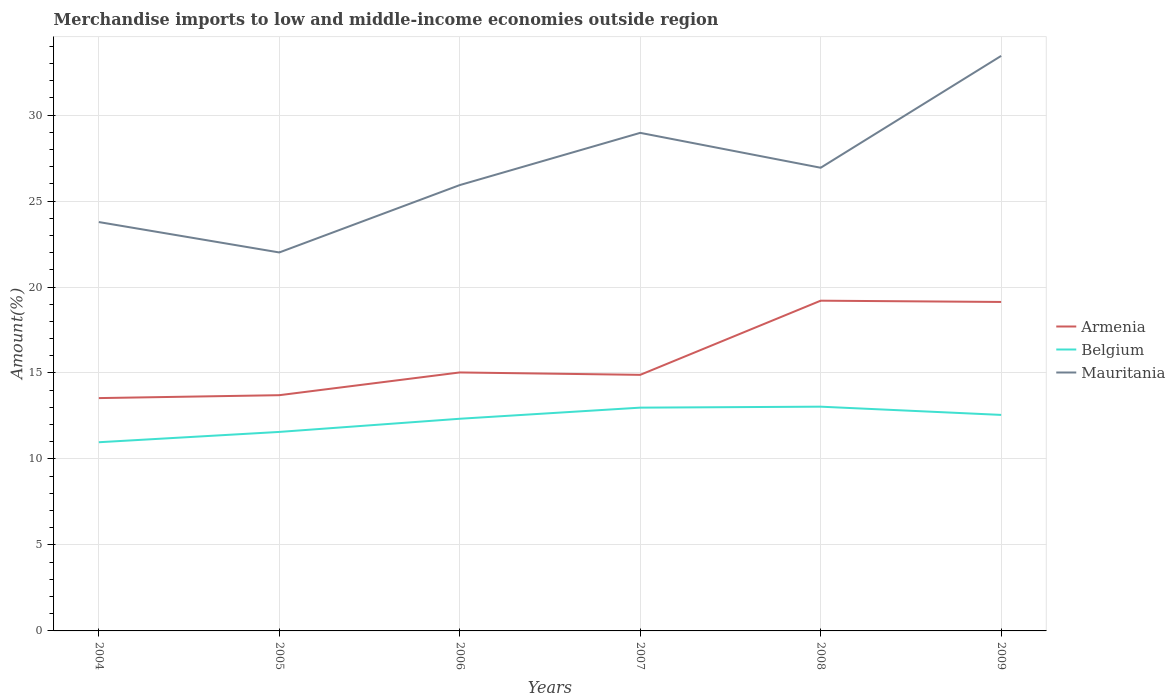Is the number of lines equal to the number of legend labels?
Your response must be concise. Yes. Across all years, what is the maximum percentage of amount earned from merchandise imports in Armenia?
Provide a short and direct response. 13.54. What is the total percentage of amount earned from merchandise imports in Armenia in the graph?
Provide a short and direct response. -4.17. What is the difference between the highest and the second highest percentage of amount earned from merchandise imports in Mauritania?
Keep it short and to the point. 11.43. What is the difference between the highest and the lowest percentage of amount earned from merchandise imports in Mauritania?
Your response must be concise. 3. Is the percentage of amount earned from merchandise imports in Belgium strictly greater than the percentage of amount earned from merchandise imports in Mauritania over the years?
Make the answer very short. Yes. How many lines are there?
Your response must be concise. 3. How many years are there in the graph?
Your answer should be compact. 6. Does the graph contain grids?
Provide a succinct answer. Yes. How many legend labels are there?
Your answer should be very brief. 3. How are the legend labels stacked?
Your response must be concise. Vertical. What is the title of the graph?
Keep it short and to the point. Merchandise imports to low and middle-income economies outside region. What is the label or title of the Y-axis?
Your answer should be compact. Amount(%). What is the Amount(%) of Armenia in 2004?
Your response must be concise. 13.54. What is the Amount(%) in Belgium in 2004?
Your answer should be very brief. 10.97. What is the Amount(%) of Mauritania in 2004?
Offer a terse response. 23.78. What is the Amount(%) in Armenia in 2005?
Keep it short and to the point. 13.71. What is the Amount(%) in Belgium in 2005?
Keep it short and to the point. 11.57. What is the Amount(%) in Mauritania in 2005?
Your response must be concise. 22.01. What is the Amount(%) in Armenia in 2006?
Your answer should be compact. 15.03. What is the Amount(%) in Belgium in 2006?
Ensure brevity in your answer.  12.34. What is the Amount(%) of Mauritania in 2006?
Provide a succinct answer. 25.93. What is the Amount(%) in Armenia in 2007?
Provide a succinct answer. 14.89. What is the Amount(%) of Belgium in 2007?
Offer a very short reply. 12.98. What is the Amount(%) of Mauritania in 2007?
Your answer should be compact. 28.96. What is the Amount(%) of Armenia in 2008?
Give a very brief answer. 19.2. What is the Amount(%) in Belgium in 2008?
Make the answer very short. 13.04. What is the Amount(%) of Mauritania in 2008?
Give a very brief answer. 26.94. What is the Amount(%) in Armenia in 2009?
Keep it short and to the point. 19.13. What is the Amount(%) of Belgium in 2009?
Give a very brief answer. 12.56. What is the Amount(%) in Mauritania in 2009?
Your response must be concise. 33.44. Across all years, what is the maximum Amount(%) in Armenia?
Your answer should be very brief. 19.2. Across all years, what is the maximum Amount(%) of Belgium?
Your answer should be compact. 13.04. Across all years, what is the maximum Amount(%) of Mauritania?
Offer a very short reply. 33.44. Across all years, what is the minimum Amount(%) of Armenia?
Provide a succinct answer. 13.54. Across all years, what is the minimum Amount(%) in Belgium?
Your answer should be compact. 10.97. Across all years, what is the minimum Amount(%) of Mauritania?
Offer a terse response. 22.01. What is the total Amount(%) in Armenia in the graph?
Make the answer very short. 95.51. What is the total Amount(%) in Belgium in the graph?
Provide a succinct answer. 73.47. What is the total Amount(%) of Mauritania in the graph?
Provide a short and direct response. 161.05. What is the difference between the Amount(%) of Armenia in 2004 and that in 2005?
Provide a short and direct response. -0.17. What is the difference between the Amount(%) in Belgium in 2004 and that in 2005?
Keep it short and to the point. -0.6. What is the difference between the Amount(%) of Mauritania in 2004 and that in 2005?
Ensure brevity in your answer.  1.77. What is the difference between the Amount(%) of Armenia in 2004 and that in 2006?
Give a very brief answer. -1.49. What is the difference between the Amount(%) in Belgium in 2004 and that in 2006?
Your response must be concise. -1.36. What is the difference between the Amount(%) of Mauritania in 2004 and that in 2006?
Keep it short and to the point. -2.15. What is the difference between the Amount(%) of Armenia in 2004 and that in 2007?
Provide a short and direct response. -1.35. What is the difference between the Amount(%) in Belgium in 2004 and that in 2007?
Provide a succinct answer. -2.01. What is the difference between the Amount(%) in Mauritania in 2004 and that in 2007?
Keep it short and to the point. -5.19. What is the difference between the Amount(%) of Armenia in 2004 and that in 2008?
Your answer should be compact. -5.66. What is the difference between the Amount(%) of Belgium in 2004 and that in 2008?
Provide a short and direct response. -2.07. What is the difference between the Amount(%) in Mauritania in 2004 and that in 2008?
Make the answer very short. -3.16. What is the difference between the Amount(%) of Armenia in 2004 and that in 2009?
Keep it short and to the point. -5.59. What is the difference between the Amount(%) of Belgium in 2004 and that in 2009?
Ensure brevity in your answer.  -1.59. What is the difference between the Amount(%) of Mauritania in 2004 and that in 2009?
Ensure brevity in your answer.  -9.66. What is the difference between the Amount(%) of Armenia in 2005 and that in 2006?
Give a very brief answer. -1.32. What is the difference between the Amount(%) of Belgium in 2005 and that in 2006?
Offer a terse response. -0.77. What is the difference between the Amount(%) of Mauritania in 2005 and that in 2006?
Your answer should be very brief. -3.92. What is the difference between the Amount(%) in Armenia in 2005 and that in 2007?
Your answer should be compact. -1.18. What is the difference between the Amount(%) in Belgium in 2005 and that in 2007?
Keep it short and to the point. -1.41. What is the difference between the Amount(%) of Mauritania in 2005 and that in 2007?
Offer a terse response. -6.95. What is the difference between the Amount(%) of Armenia in 2005 and that in 2008?
Your answer should be compact. -5.5. What is the difference between the Amount(%) in Belgium in 2005 and that in 2008?
Provide a short and direct response. -1.47. What is the difference between the Amount(%) of Mauritania in 2005 and that in 2008?
Offer a very short reply. -4.93. What is the difference between the Amount(%) in Armenia in 2005 and that in 2009?
Ensure brevity in your answer.  -5.42. What is the difference between the Amount(%) of Belgium in 2005 and that in 2009?
Keep it short and to the point. -0.99. What is the difference between the Amount(%) in Mauritania in 2005 and that in 2009?
Offer a very short reply. -11.43. What is the difference between the Amount(%) in Armenia in 2006 and that in 2007?
Offer a very short reply. 0.14. What is the difference between the Amount(%) of Belgium in 2006 and that in 2007?
Offer a terse response. -0.65. What is the difference between the Amount(%) in Mauritania in 2006 and that in 2007?
Your response must be concise. -3.04. What is the difference between the Amount(%) of Armenia in 2006 and that in 2008?
Provide a short and direct response. -4.17. What is the difference between the Amount(%) of Belgium in 2006 and that in 2008?
Provide a short and direct response. -0.7. What is the difference between the Amount(%) of Mauritania in 2006 and that in 2008?
Keep it short and to the point. -1.01. What is the difference between the Amount(%) of Armenia in 2006 and that in 2009?
Offer a very short reply. -4.1. What is the difference between the Amount(%) of Belgium in 2006 and that in 2009?
Make the answer very short. -0.22. What is the difference between the Amount(%) of Mauritania in 2006 and that in 2009?
Provide a short and direct response. -7.51. What is the difference between the Amount(%) in Armenia in 2007 and that in 2008?
Offer a very short reply. -4.31. What is the difference between the Amount(%) of Belgium in 2007 and that in 2008?
Offer a terse response. -0.06. What is the difference between the Amount(%) of Mauritania in 2007 and that in 2008?
Your answer should be compact. 2.03. What is the difference between the Amount(%) of Armenia in 2007 and that in 2009?
Keep it short and to the point. -4.24. What is the difference between the Amount(%) in Belgium in 2007 and that in 2009?
Your answer should be very brief. 0.42. What is the difference between the Amount(%) in Mauritania in 2007 and that in 2009?
Give a very brief answer. -4.48. What is the difference between the Amount(%) of Armenia in 2008 and that in 2009?
Offer a very short reply. 0.07. What is the difference between the Amount(%) in Belgium in 2008 and that in 2009?
Provide a succinct answer. 0.48. What is the difference between the Amount(%) of Mauritania in 2008 and that in 2009?
Your answer should be compact. -6.5. What is the difference between the Amount(%) in Armenia in 2004 and the Amount(%) in Belgium in 2005?
Your response must be concise. 1.97. What is the difference between the Amount(%) of Armenia in 2004 and the Amount(%) of Mauritania in 2005?
Give a very brief answer. -8.47. What is the difference between the Amount(%) in Belgium in 2004 and the Amount(%) in Mauritania in 2005?
Keep it short and to the point. -11.04. What is the difference between the Amount(%) of Armenia in 2004 and the Amount(%) of Belgium in 2006?
Offer a very short reply. 1.2. What is the difference between the Amount(%) in Armenia in 2004 and the Amount(%) in Mauritania in 2006?
Offer a very short reply. -12.39. What is the difference between the Amount(%) of Belgium in 2004 and the Amount(%) of Mauritania in 2006?
Provide a short and direct response. -14.95. What is the difference between the Amount(%) in Armenia in 2004 and the Amount(%) in Belgium in 2007?
Offer a very short reply. 0.56. What is the difference between the Amount(%) in Armenia in 2004 and the Amount(%) in Mauritania in 2007?
Keep it short and to the point. -15.42. What is the difference between the Amount(%) in Belgium in 2004 and the Amount(%) in Mauritania in 2007?
Provide a succinct answer. -17.99. What is the difference between the Amount(%) in Armenia in 2004 and the Amount(%) in Belgium in 2008?
Your answer should be very brief. 0.5. What is the difference between the Amount(%) of Armenia in 2004 and the Amount(%) of Mauritania in 2008?
Provide a succinct answer. -13.4. What is the difference between the Amount(%) in Belgium in 2004 and the Amount(%) in Mauritania in 2008?
Your answer should be very brief. -15.96. What is the difference between the Amount(%) in Armenia in 2004 and the Amount(%) in Belgium in 2009?
Provide a succinct answer. 0.98. What is the difference between the Amount(%) in Armenia in 2004 and the Amount(%) in Mauritania in 2009?
Offer a very short reply. -19.9. What is the difference between the Amount(%) of Belgium in 2004 and the Amount(%) of Mauritania in 2009?
Offer a very short reply. -22.47. What is the difference between the Amount(%) in Armenia in 2005 and the Amount(%) in Belgium in 2006?
Keep it short and to the point. 1.37. What is the difference between the Amount(%) of Armenia in 2005 and the Amount(%) of Mauritania in 2006?
Your answer should be compact. -12.22. What is the difference between the Amount(%) of Belgium in 2005 and the Amount(%) of Mauritania in 2006?
Make the answer very short. -14.35. What is the difference between the Amount(%) in Armenia in 2005 and the Amount(%) in Belgium in 2007?
Your answer should be compact. 0.72. What is the difference between the Amount(%) of Armenia in 2005 and the Amount(%) of Mauritania in 2007?
Offer a very short reply. -15.26. What is the difference between the Amount(%) of Belgium in 2005 and the Amount(%) of Mauritania in 2007?
Provide a succinct answer. -17.39. What is the difference between the Amount(%) of Armenia in 2005 and the Amount(%) of Belgium in 2008?
Your answer should be very brief. 0.67. What is the difference between the Amount(%) of Armenia in 2005 and the Amount(%) of Mauritania in 2008?
Provide a short and direct response. -13.23. What is the difference between the Amount(%) in Belgium in 2005 and the Amount(%) in Mauritania in 2008?
Offer a terse response. -15.36. What is the difference between the Amount(%) of Armenia in 2005 and the Amount(%) of Belgium in 2009?
Ensure brevity in your answer.  1.15. What is the difference between the Amount(%) in Armenia in 2005 and the Amount(%) in Mauritania in 2009?
Keep it short and to the point. -19.73. What is the difference between the Amount(%) of Belgium in 2005 and the Amount(%) of Mauritania in 2009?
Your answer should be compact. -21.87. What is the difference between the Amount(%) in Armenia in 2006 and the Amount(%) in Belgium in 2007?
Make the answer very short. 2.05. What is the difference between the Amount(%) in Armenia in 2006 and the Amount(%) in Mauritania in 2007?
Offer a terse response. -13.93. What is the difference between the Amount(%) of Belgium in 2006 and the Amount(%) of Mauritania in 2007?
Ensure brevity in your answer.  -16.63. What is the difference between the Amount(%) of Armenia in 2006 and the Amount(%) of Belgium in 2008?
Your response must be concise. 1.99. What is the difference between the Amount(%) of Armenia in 2006 and the Amount(%) of Mauritania in 2008?
Your answer should be very brief. -11.9. What is the difference between the Amount(%) in Belgium in 2006 and the Amount(%) in Mauritania in 2008?
Keep it short and to the point. -14.6. What is the difference between the Amount(%) in Armenia in 2006 and the Amount(%) in Belgium in 2009?
Keep it short and to the point. 2.47. What is the difference between the Amount(%) of Armenia in 2006 and the Amount(%) of Mauritania in 2009?
Provide a succinct answer. -18.41. What is the difference between the Amount(%) in Belgium in 2006 and the Amount(%) in Mauritania in 2009?
Give a very brief answer. -21.1. What is the difference between the Amount(%) of Armenia in 2007 and the Amount(%) of Belgium in 2008?
Provide a short and direct response. 1.85. What is the difference between the Amount(%) of Armenia in 2007 and the Amount(%) of Mauritania in 2008?
Keep it short and to the point. -12.04. What is the difference between the Amount(%) of Belgium in 2007 and the Amount(%) of Mauritania in 2008?
Your answer should be compact. -13.95. What is the difference between the Amount(%) of Armenia in 2007 and the Amount(%) of Belgium in 2009?
Offer a very short reply. 2.33. What is the difference between the Amount(%) of Armenia in 2007 and the Amount(%) of Mauritania in 2009?
Keep it short and to the point. -18.55. What is the difference between the Amount(%) in Belgium in 2007 and the Amount(%) in Mauritania in 2009?
Your response must be concise. -20.46. What is the difference between the Amount(%) in Armenia in 2008 and the Amount(%) in Belgium in 2009?
Give a very brief answer. 6.64. What is the difference between the Amount(%) of Armenia in 2008 and the Amount(%) of Mauritania in 2009?
Offer a terse response. -14.24. What is the difference between the Amount(%) in Belgium in 2008 and the Amount(%) in Mauritania in 2009?
Your answer should be compact. -20.4. What is the average Amount(%) in Armenia per year?
Ensure brevity in your answer.  15.92. What is the average Amount(%) in Belgium per year?
Keep it short and to the point. 12.24. What is the average Amount(%) in Mauritania per year?
Provide a short and direct response. 26.84. In the year 2004, what is the difference between the Amount(%) of Armenia and Amount(%) of Belgium?
Your answer should be compact. 2.57. In the year 2004, what is the difference between the Amount(%) of Armenia and Amount(%) of Mauritania?
Make the answer very short. -10.24. In the year 2004, what is the difference between the Amount(%) of Belgium and Amount(%) of Mauritania?
Offer a terse response. -12.8. In the year 2005, what is the difference between the Amount(%) in Armenia and Amount(%) in Belgium?
Ensure brevity in your answer.  2.14. In the year 2005, what is the difference between the Amount(%) in Armenia and Amount(%) in Mauritania?
Ensure brevity in your answer.  -8.3. In the year 2005, what is the difference between the Amount(%) of Belgium and Amount(%) of Mauritania?
Your answer should be compact. -10.44. In the year 2006, what is the difference between the Amount(%) of Armenia and Amount(%) of Belgium?
Ensure brevity in your answer.  2.69. In the year 2006, what is the difference between the Amount(%) in Armenia and Amount(%) in Mauritania?
Give a very brief answer. -10.9. In the year 2006, what is the difference between the Amount(%) in Belgium and Amount(%) in Mauritania?
Ensure brevity in your answer.  -13.59. In the year 2007, what is the difference between the Amount(%) of Armenia and Amount(%) of Belgium?
Give a very brief answer. 1.91. In the year 2007, what is the difference between the Amount(%) in Armenia and Amount(%) in Mauritania?
Make the answer very short. -14.07. In the year 2007, what is the difference between the Amount(%) in Belgium and Amount(%) in Mauritania?
Make the answer very short. -15.98. In the year 2008, what is the difference between the Amount(%) of Armenia and Amount(%) of Belgium?
Ensure brevity in your answer.  6.16. In the year 2008, what is the difference between the Amount(%) in Armenia and Amount(%) in Mauritania?
Your answer should be compact. -7.73. In the year 2008, what is the difference between the Amount(%) of Belgium and Amount(%) of Mauritania?
Your response must be concise. -13.9. In the year 2009, what is the difference between the Amount(%) in Armenia and Amount(%) in Belgium?
Offer a terse response. 6.57. In the year 2009, what is the difference between the Amount(%) of Armenia and Amount(%) of Mauritania?
Your answer should be compact. -14.31. In the year 2009, what is the difference between the Amount(%) in Belgium and Amount(%) in Mauritania?
Give a very brief answer. -20.88. What is the ratio of the Amount(%) of Armenia in 2004 to that in 2005?
Offer a very short reply. 0.99. What is the ratio of the Amount(%) of Belgium in 2004 to that in 2005?
Make the answer very short. 0.95. What is the ratio of the Amount(%) in Mauritania in 2004 to that in 2005?
Your response must be concise. 1.08. What is the ratio of the Amount(%) in Armenia in 2004 to that in 2006?
Make the answer very short. 0.9. What is the ratio of the Amount(%) in Belgium in 2004 to that in 2006?
Keep it short and to the point. 0.89. What is the ratio of the Amount(%) of Mauritania in 2004 to that in 2006?
Your answer should be very brief. 0.92. What is the ratio of the Amount(%) of Armenia in 2004 to that in 2007?
Offer a very short reply. 0.91. What is the ratio of the Amount(%) in Belgium in 2004 to that in 2007?
Ensure brevity in your answer.  0.85. What is the ratio of the Amount(%) in Mauritania in 2004 to that in 2007?
Provide a short and direct response. 0.82. What is the ratio of the Amount(%) of Armenia in 2004 to that in 2008?
Offer a very short reply. 0.7. What is the ratio of the Amount(%) of Belgium in 2004 to that in 2008?
Your answer should be compact. 0.84. What is the ratio of the Amount(%) in Mauritania in 2004 to that in 2008?
Offer a terse response. 0.88. What is the ratio of the Amount(%) of Armenia in 2004 to that in 2009?
Ensure brevity in your answer.  0.71. What is the ratio of the Amount(%) in Belgium in 2004 to that in 2009?
Offer a terse response. 0.87. What is the ratio of the Amount(%) of Mauritania in 2004 to that in 2009?
Provide a succinct answer. 0.71. What is the ratio of the Amount(%) in Armenia in 2005 to that in 2006?
Offer a terse response. 0.91. What is the ratio of the Amount(%) in Belgium in 2005 to that in 2006?
Keep it short and to the point. 0.94. What is the ratio of the Amount(%) of Mauritania in 2005 to that in 2006?
Provide a short and direct response. 0.85. What is the ratio of the Amount(%) of Armenia in 2005 to that in 2007?
Offer a very short reply. 0.92. What is the ratio of the Amount(%) in Belgium in 2005 to that in 2007?
Your answer should be very brief. 0.89. What is the ratio of the Amount(%) of Mauritania in 2005 to that in 2007?
Provide a short and direct response. 0.76. What is the ratio of the Amount(%) in Armenia in 2005 to that in 2008?
Ensure brevity in your answer.  0.71. What is the ratio of the Amount(%) of Belgium in 2005 to that in 2008?
Provide a short and direct response. 0.89. What is the ratio of the Amount(%) of Mauritania in 2005 to that in 2008?
Ensure brevity in your answer.  0.82. What is the ratio of the Amount(%) in Armenia in 2005 to that in 2009?
Your answer should be compact. 0.72. What is the ratio of the Amount(%) of Belgium in 2005 to that in 2009?
Provide a short and direct response. 0.92. What is the ratio of the Amount(%) of Mauritania in 2005 to that in 2009?
Your answer should be very brief. 0.66. What is the ratio of the Amount(%) in Armenia in 2006 to that in 2007?
Keep it short and to the point. 1.01. What is the ratio of the Amount(%) of Belgium in 2006 to that in 2007?
Provide a succinct answer. 0.95. What is the ratio of the Amount(%) of Mauritania in 2006 to that in 2007?
Keep it short and to the point. 0.9. What is the ratio of the Amount(%) of Armenia in 2006 to that in 2008?
Offer a very short reply. 0.78. What is the ratio of the Amount(%) in Belgium in 2006 to that in 2008?
Provide a short and direct response. 0.95. What is the ratio of the Amount(%) in Mauritania in 2006 to that in 2008?
Keep it short and to the point. 0.96. What is the ratio of the Amount(%) in Armenia in 2006 to that in 2009?
Make the answer very short. 0.79. What is the ratio of the Amount(%) of Belgium in 2006 to that in 2009?
Offer a terse response. 0.98. What is the ratio of the Amount(%) of Mauritania in 2006 to that in 2009?
Ensure brevity in your answer.  0.78. What is the ratio of the Amount(%) of Armenia in 2007 to that in 2008?
Make the answer very short. 0.78. What is the ratio of the Amount(%) in Mauritania in 2007 to that in 2008?
Offer a terse response. 1.08. What is the ratio of the Amount(%) of Armenia in 2007 to that in 2009?
Your response must be concise. 0.78. What is the ratio of the Amount(%) of Belgium in 2007 to that in 2009?
Provide a short and direct response. 1.03. What is the ratio of the Amount(%) in Mauritania in 2007 to that in 2009?
Your response must be concise. 0.87. What is the ratio of the Amount(%) of Armenia in 2008 to that in 2009?
Give a very brief answer. 1. What is the ratio of the Amount(%) of Belgium in 2008 to that in 2009?
Offer a very short reply. 1.04. What is the ratio of the Amount(%) in Mauritania in 2008 to that in 2009?
Offer a terse response. 0.81. What is the difference between the highest and the second highest Amount(%) in Armenia?
Offer a terse response. 0.07. What is the difference between the highest and the second highest Amount(%) of Belgium?
Your answer should be very brief. 0.06. What is the difference between the highest and the second highest Amount(%) in Mauritania?
Provide a succinct answer. 4.48. What is the difference between the highest and the lowest Amount(%) in Armenia?
Your response must be concise. 5.66. What is the difference between the highest and the lowest Amount(%) in Belgium?
Your response must be concise. 2.07. What is the difference between the highest and the lowest Amount(%) in Mauritania?
Ensure brevity in your answer.  11.43. 